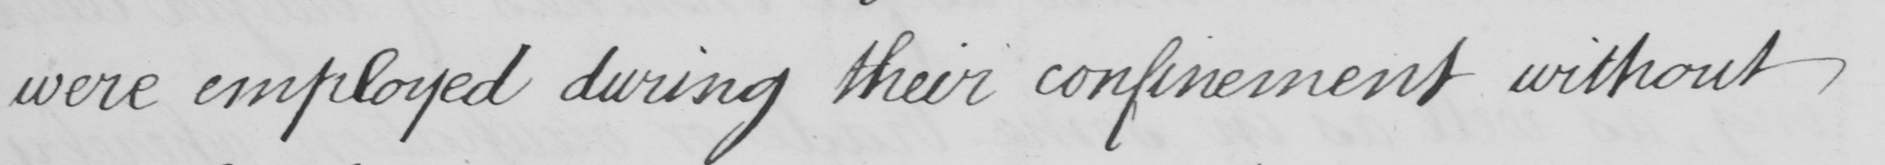Please transcribe the handwritten text in this image. were employed during their confinement without 